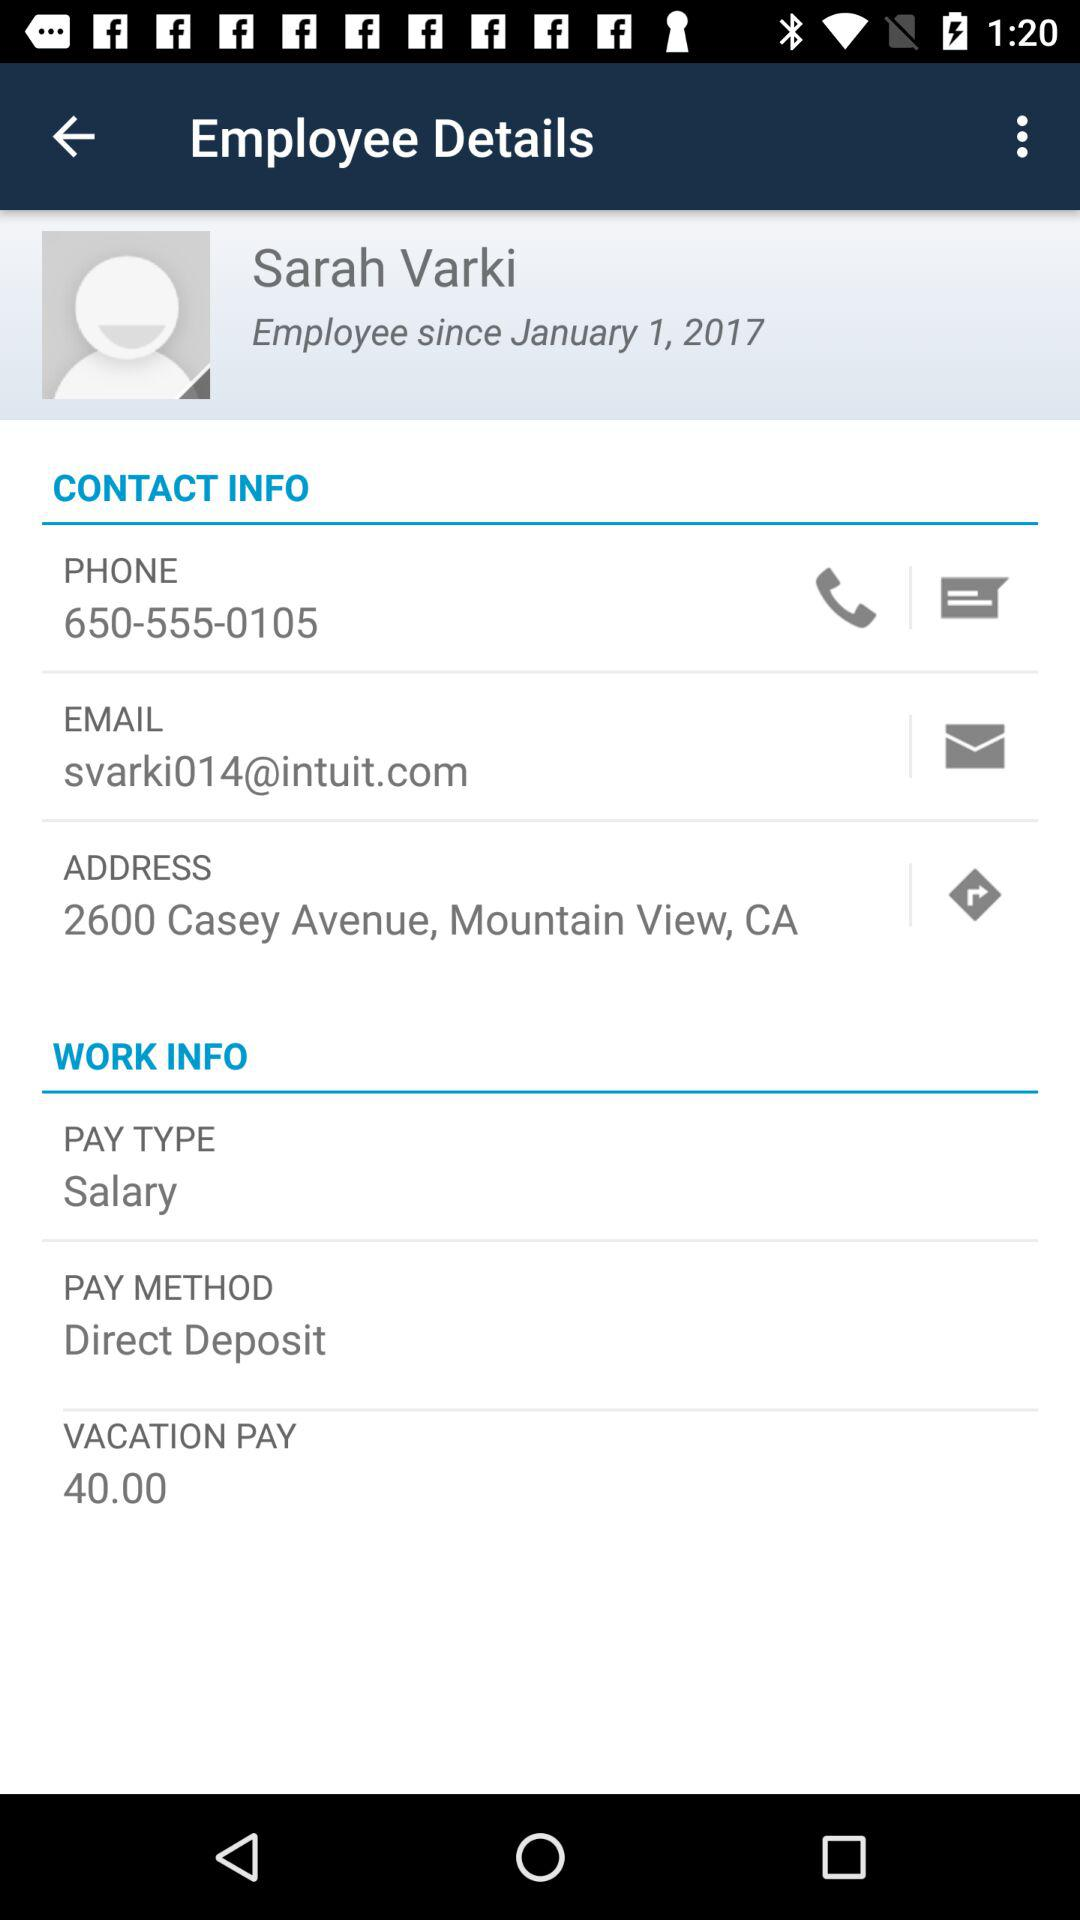What is the phone number of an employee? The phone number is 650-555-0105. 